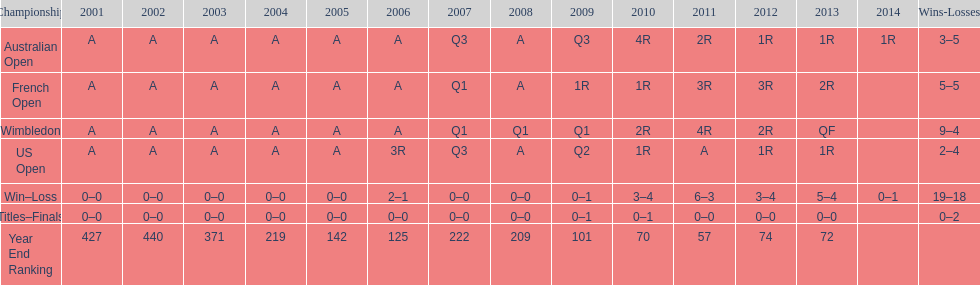Which tournament has the largest total win record? Wimbledon. 